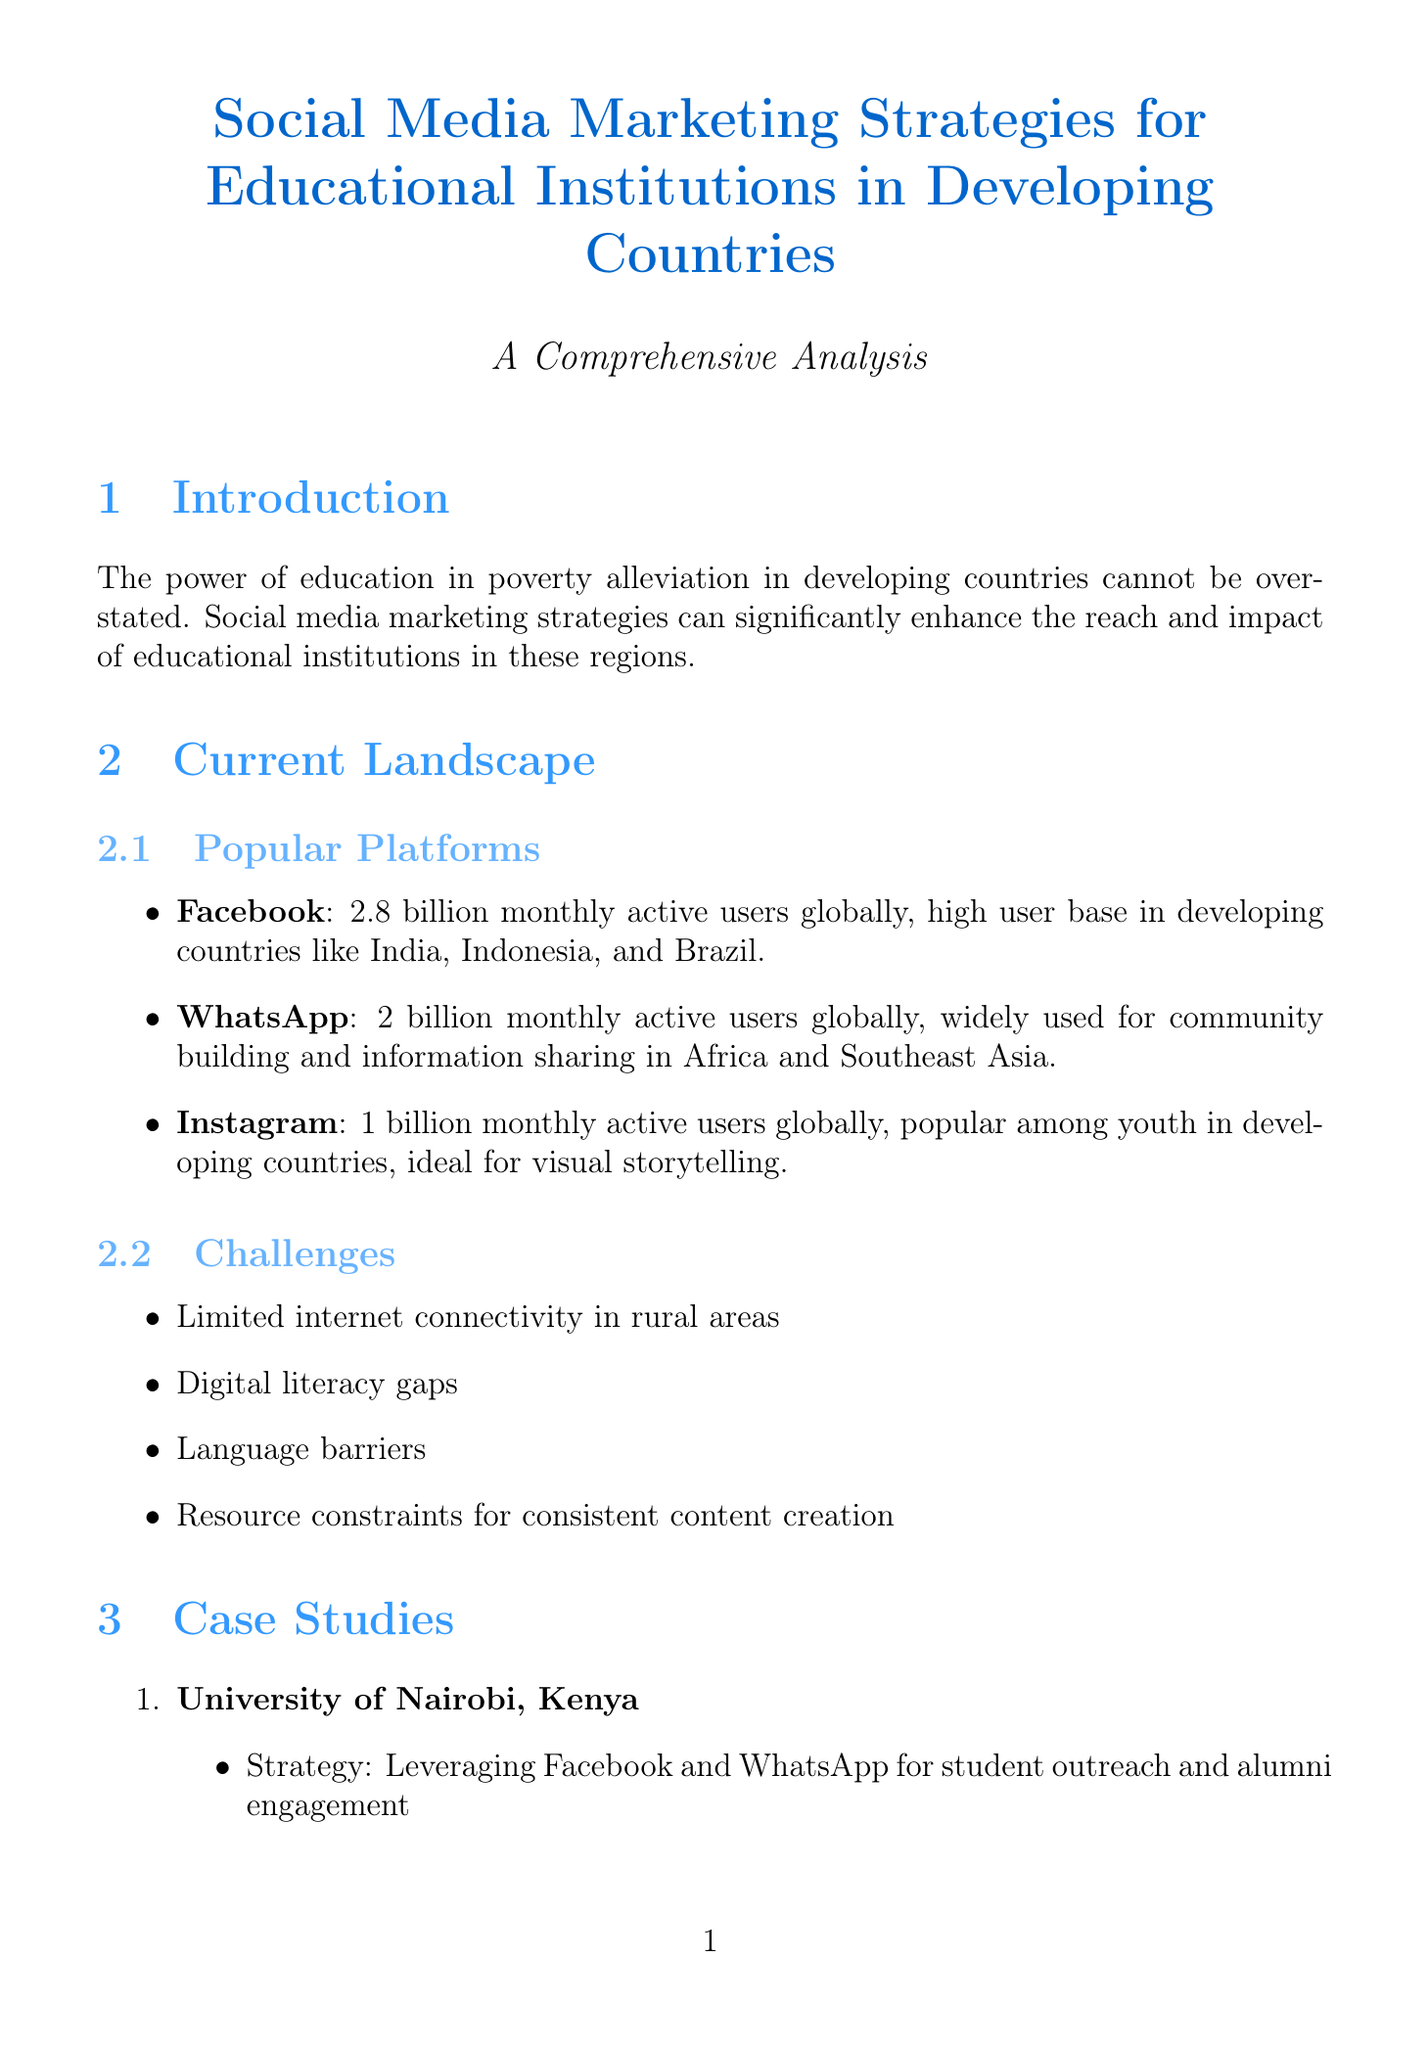What is the thesis of the report? The thesis highlights that social media marketing strategies can significantly enhance the reach and impact of educational institutions in developing countries.
Answer: Social media marketing strategies can significantly enhance the reach and impact of educational institutions in developing countries How many monthly active users does Facebook have? The document states that Facebook has 2.8 billion monthly active users globally.
Answer: 2.8 billion What challenge is related to rural areas mentioned in the report? The report mentions limited internet connectivity in rural areas as a challenge.
Answer: Limited internet connectivity Which institution achieved a 40% increase in international student applications? Ateneo de Manila University in the Philippines achieved this increase according to the case studies.
Answer: Ateneo de Manila University What is one best practice for content creation in local languages? The document suggests creating content in local languages alongside English.
Answer: Create content in local languages alongside English Which tool is used to track website traffic from social media campaigns? Google Analytics is the tool specified for tracking website traffic from social media campaigns.
Answer: Google Analytics What future trend could enhance targeting and engagement of prospective students? The trend of Artificial Intelligence in content personalization is noted as having potential impact in this area.
Answer: Artificial Intelligence in content personalization How much did alumni donations improve for the University of Nairobi? The report states that alumni donations improved by 35%.
Answer: 35% What is the call to action for educational institutions in developing countries? The call to action emphasizes that they must prioritize and invest in comprehensive social media marketing strategies.
Answer: Prioritize and invest in comprehensive social media marketing strategies 